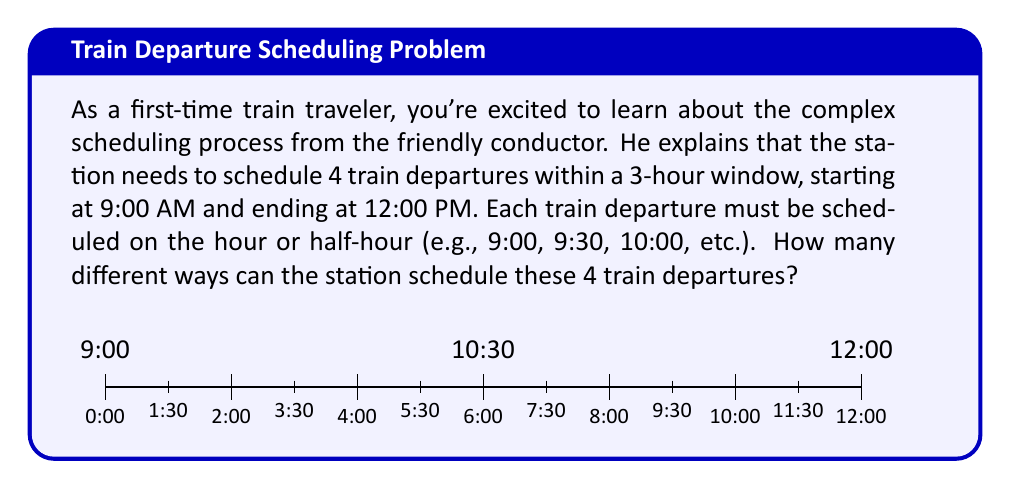Provide a solution to this math problem. Let's approach this step-by-step:

1) First, we need to determine how many possible time slots are available. In a 3-hour window with departures on the hour and half-hour, we have:
   $$ 3 \text{ hours} \times 2 \text{ slots per hour} = 6 \text{ total slots} $$

2) Our problem is essentially asking: in how many ways can we choose 4 slots out of these 6 available slots?

3) This is a combination problem. We use the combination formula:
   $$ C(n,r) = \binom{n}{r} = \frac{n!}{r!(n-r)!} $$
   Where $n$ is the total number of items to choose from, and $r$ is the number of items being chosen.

4) In our case, $n = 6$ (total slots) and $r = 4$ (train departures to schedule).

5) Plugging these values into the formula:
   $$ C(6,4) = \binom{6}{4} = \frac{6!}{4!(6-4)!} = \frac{6!}{4!2!} $$

6) Expanding this:
   $$ \frac{6 \times 5 \times 4!}{4! \times 2 \times 1} $$

7) The 4! cancels out in the numerator and denominator:
   $$ \frac{6 \times 5}{2 \times 1} = \frac{30}{2} = 15 $$

Therefore, there are 15 different ways to schedule the 4 train departures.
Answer: 15 